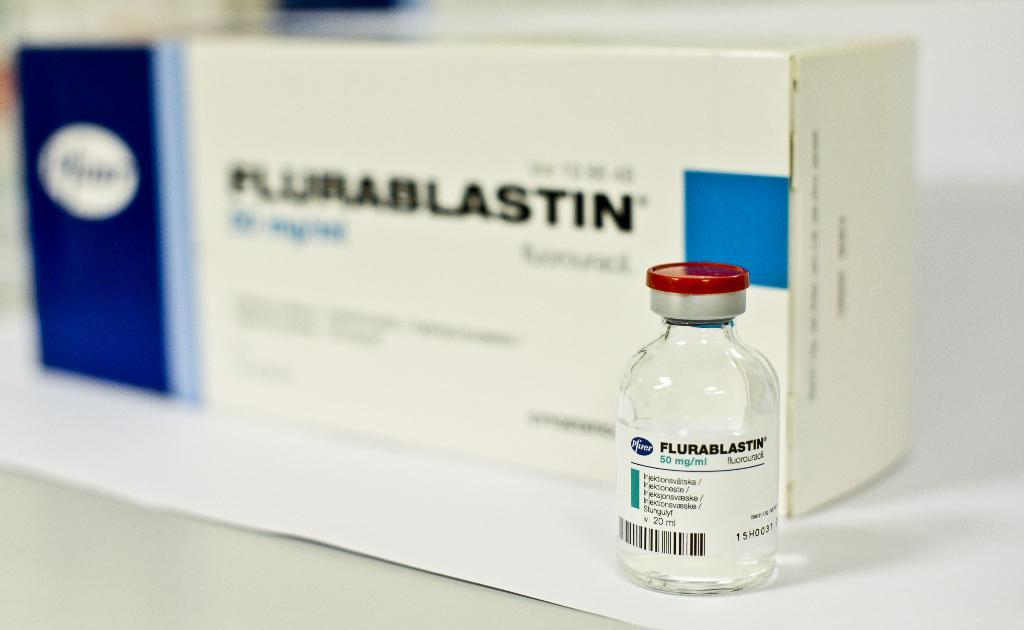<image>
Offer a succinct explanation of the picture presented. A vial of Flurablastin medicine on top of a white surface and in front of the box of the same medication. 